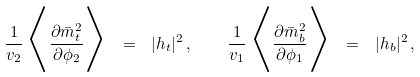Convert formula to latex. <formula><loc_0><loc_0><loc_500><loc_500>\frac { 1 } { v _ { 2 } } \, \Big < \frac { \partial \bar { m } ^ { 2 } _ { t } } { \partial \phi _ { 2 } } \Big > \ = \ | h _ { t } | ^ { 2 } \, , \quad \frac { 1 } { v _ { 1 } } \, \Big < \frac { \partial \bar { m } ^ { 2 } _ { b } } { \partial \phi _ { 1 } } \Big > \ = \ | h _ { b } | ^ { 2 } \, ,</formula> 